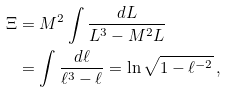Convert formula to latex. <formula><loc_0><loc_0><loc_500><loc_500>\Xi & = M ^ { 2 } \int \frac { d L } { L ^ { 3 } - M ^ { 2 } L } \\ & = \int \frac { d \ell } { \ell ^ { 3 } - \ell } = \ln \sqrt { 1 - \ell ^ { - 2 } } \, ,</formula> 